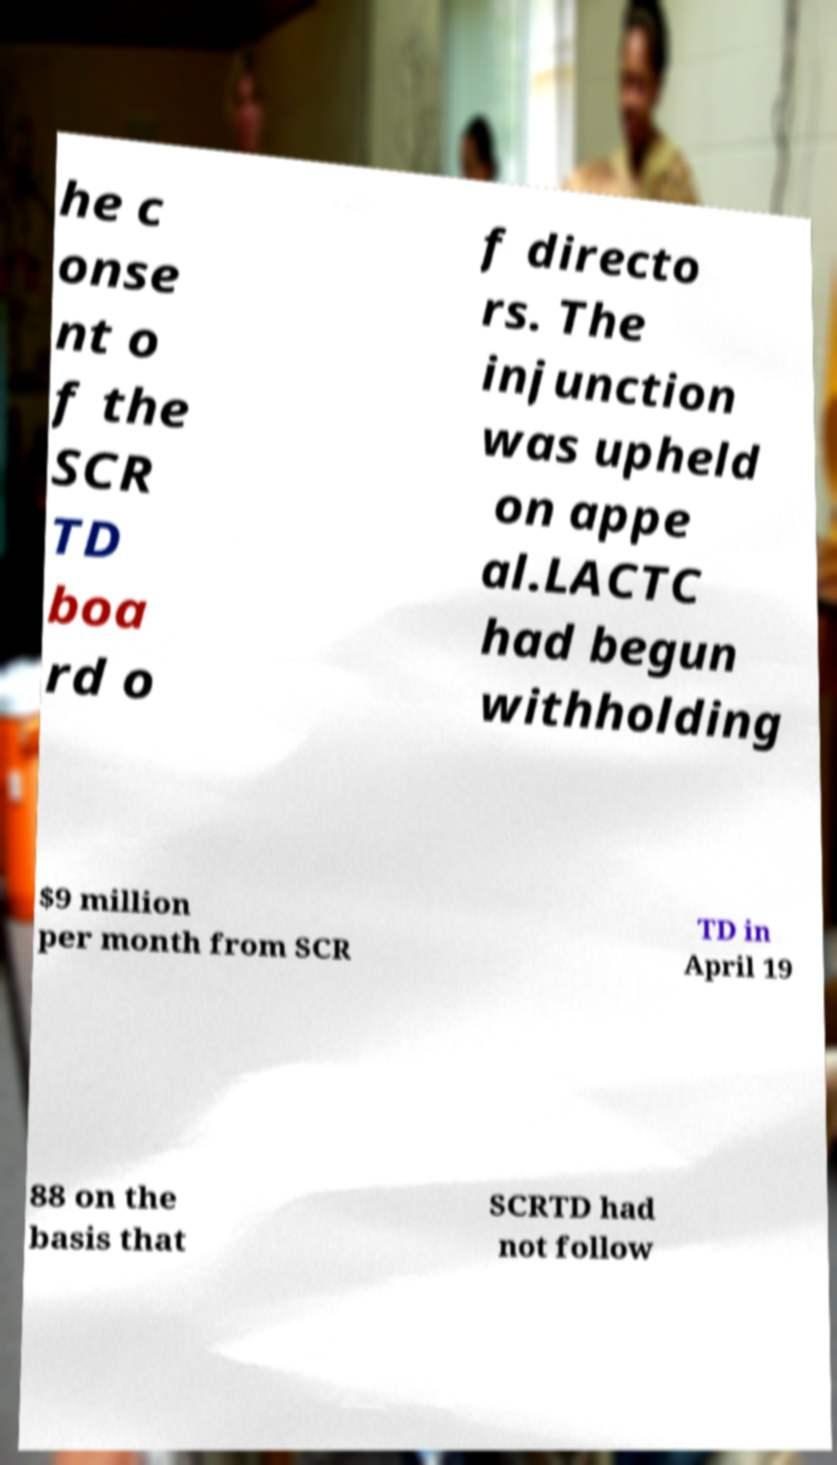Please read and relay the text visible in this image. What does it say? he c onse nt o f the SCR TD boa rd o f directo rs. The injunction was upheld on appe al.LACTC had begun withholding $9 million per month from SCR TD in April 19 88 on the basis that SCRTD had not follow 